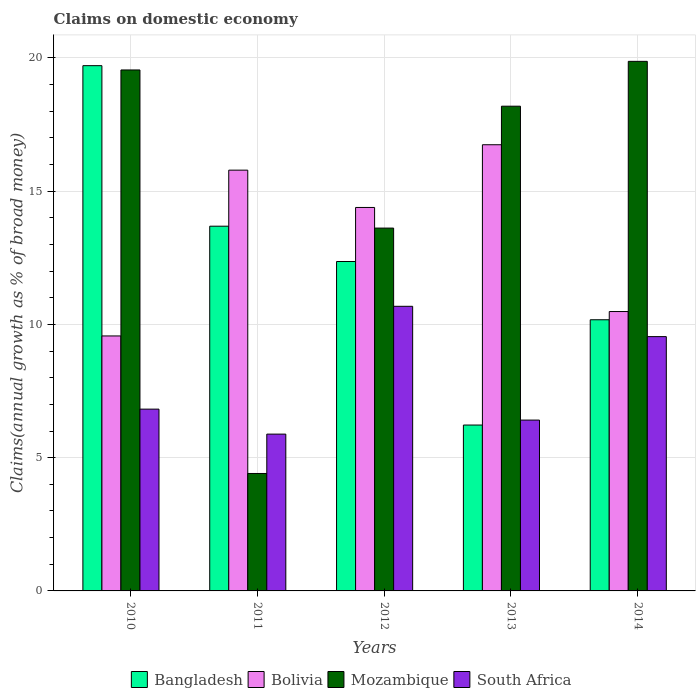How many different coloured bars are there?
Ensure brevity in your answer.  4. How many bars are there on the 5th tick from the left?
Your answer should be very brief. 4. In how many cases, is the number of bars for a given year not equal to the number of legend labels?
Ensure brevity in your answer.  0. What is the percentage of broad money claimed on domestic economy in Bolivia in 2012?
Your answer should be compact. 14.39. Across all years, what is the maximum percentage of broad money claimed on domestic economy in Bangladesh?
Your answer should be very brief. 19.71. Across all years, what is the minimum percentage of broad money claimed on domestic economy in Bolivia?
Offer a terse response. 9.57. In which year was the percentage of broad money claimed on domestic economy in Bangladesh maximum?
Offer a very short reply. 2010. What is the total percentage of broad money claimed on domestic economy in Bangladesh in the graph?
Offer a very short reply. 62.16. What is the difference between the percentage of broad money claimed on domestic economy in Bangladesh in 2013 and that in 2014?
Offer a terse response. -3.95. What is the difference between the percentage of broad money claimed on domestic economy in Bangladesh in 2011 and the percentage of broad money claimed on domestic economy in South Africa in 2012?
Provide a short and direct response. 3.01. What is the average percentage of broad money claimed on domestic economy in Bolivia per year?
Offer a very short reply. 13.39. In the year 2014, what is the difference between the percentage of broad money claimed on domestic economy in Bolivia and percentage of broad money claimed on domestic economy in South Africa?
Give a very brief answer. 0.94. What is the ratio of the percentage of broad money claimed on domestic economy in Bolivia in 2013 to that in 2014?
Give a very brief answer. 1.6. What is the difference between the highest and the second highest percentage of broad money claimed on domestic economy in South Africa?
Ensure brevity in your answer.  1.14. What is the difference between the highest and the lowest percentage of broad money claimed on domestic economy in South Africa?
Offer a very short reply. 4.8. In how many years, is the percentage of broad money claimed on domestic economy in South Africa greater than the average percentage of broad money claimed on domestic economy in South Africa taken over all years?
Your answer should be very brief. 2. Is the sum of the percentage of broad money claimed on domestic economy in South Africa in 2010 and 2012 greater than the maximum percentage of broad money claimed on domestic economy in Mozambique across all years?
Provide a short and direct response. No. Is it the case that in every year, the sum of the percentage of broad money claimed on domestic economy in Mozambique and percentage of broad money claimed on domestic economy in Bolivia is greater than the sum of percentage of broad money claimed on domestic economy in South Africa and percentage of broad money claimed on domestic economy in Bangladesh?
Offer a very short reply. Yes. What does the 4th bar from the right in 2011 represents?
Make the answer very short. Bangladesh. How many years are there in the graph?
Your answer should be very brief. 5. Does the graph contain any zero values?
Your answer should be compact. No. What is the title of the graph?
Your answer should be very brief. Claims on domestic economy. Does "Belize" appear as one of the legend labels in the graph?
Offer a terse response. No. What is the label or title of the Y-axis?
Your response must be concise. Claims(annual growth as % of broad money). What is the Claims(annual growth as % of broad money) of Bangladesh in 2010?
Provide a short and direct response. 19.71. What is the Claims(annual growth as % of broad money) of Bolivia in 2010?
Ensure brevity in your answer.  9.57. What is the Claims(annual growth as % of broad money) in Mozambique in 2010?
Make the answer very short. 19.55. What is the Claims(annual growth as % of broad money) in South Africa in 2010?
Your answer should be compact. 6.82. What is the Claims(annual growth as % of broad money) of Bangladesh in 2011?
Your answer should be compact. 13.69. What is the Claims(annual growth as % of broad money) of Bolivia in 2011?
Your response must be concise. 15.79. What is the Claims(annual growth as % of broad money) in Mozambique in 2011?
Offer a very short reply. 4.41. What is the Claims(annual growth as % of broad money) of South Africa in 2011?
Provide a succinct answer. 5.88. What is the Claims(annual growth as % of broad money) of Bangladesh in 2012?
Ensure brevity in your answer.  12.36. What is the Claims(annual growth as % of broad money) in Bolivia in 2012?
Your response must be concise. 14.39. What is the Claims(annual growth as % of broad money) in Mozambique in 2012?
Give a very brief answer. 13.62. What is the Claims(annual growth as % of broad money) in South Africa in 2012?
Provide a succinct answer. 10.68. What is the Claims(annual growth as % of broad money) of Bangladesh in 2013?
Offer a very short reply. 6.22. What is the Claims(annual growth as % of broad money) in Bolivia in 2013?
Offer a terse response. 16.74. What is the Claims(annual growth as % of broad money) of Mozambique in 2013?
Make the answer very short. 18.19. What is the Claims(annual growth as % of broad money) of South Africa in 2013?
Your response must be concise. 6.41. What is the Claims(annual growth as % of broad money) in Bangladesh in 2014?
Keep it short and to the point. 10.17. What is the Claims(annual growth as % of broad money) in Bolivia in 2014?
Keep it short and to the point. 10.48. What is the Claims(annual growth as % of broad money) of Mozambique in 2014?
Your response must be concise. 19.87. What is the Claims(annual growth as % of broad money) of South Africa in 2014?
Make the answer very short. 9.54. Across all years, what is the maximum Claims(annual growth as % of broad money) of Bangladesh?
Give a very brief answer. 19.71. Across all years, what is the maximum Claims(annual growth as % of broad money) in Bolivia?
Provide a succinct answer. 16.74. Across all years, what is the maximum Claims(annual growth as % of broad money) of Mozambique?
Provide a succinct answer. 19.87. Across all years, what is the maximum Claims(annual growth as % of broad money) of South Africa?
Offer a very short reply. 10.68. Across all years, what is the minimum Claims(annual growth as % of broad money) of Bangladesh?
Make the answer very short. 6.22. Across all years, what is the minimum Claims(annual growth as % of broad money) in Bolivia?
Ensure brevity in your answer.  9.57. Across all years, what is the minimum Claims(annual growth as % of broad money) of Mozambique?
Offer a very short reply. 4.41. Across all years, what is the minimum Claims(annual growth as % of broad money) of South Africa?
Your answer should be very brief. 5.88. What is the total Claims(annual growth as % of broad money) in Bangladesh in the graph?
Offer a very short reply. 62.16. What is the total Claims(annual growth as % of broad money) in Bolivia in the graph?
Your answer should be very brief. 66.97. What is the total Claims(annual growth as % of broad money) in Mozambique in the graph?
Offer a terse response. 75.63. What is the total Claims(annual growth as % of broad money) of South Africa in the graph?
Your answer should be very brief. 39.34. What is the difference between the Claims(annual growth as % of broad money) of Bangladesh in 2010 and that in 2011?
Make the answer very short. 6.02. What is the difference between the Claims(annual growth as % of broad money) of Bolivia in 2010 and that in 2011?
Give a very brief answer. -6.22. What is the difference between the Claims(annual growth as % of broad money) in Mozambique in 2010 and that in 2011?
Provide a succinct answer. 15.14. What is the difference between the Claims(annual growth as % of broad money) of South Africa in 2010 and that in 2011?
Make the answer very short. 0.94. What is the difference between the Claims(annual growth as % of broad money) in Bangladesh in 2010 and that in 2012?
Offer a terse response. 7.35. What is the difference between the Claims(annual growth as % of broad money) in Bolivia in 2010 and that in 2012?
Your answer should be compact. -4.82. What is the difference between the Claims(annual growth as % of broad money) in Mozambique in 2010 and that in 2012?
Give a very brief answer. 5.93. What is the difference between the Claims(annual growth as % of broad money) in South Africa in 2010 and that in 2012?
Provide a succinct answer. -3.86. What is the difference between the Claims(annual growth as % of broad money) of Bangladesh in 2010 and that in 2013?
Ensure brevity in your answer.  13.49. What is the difference between the Claims(annual growth as % of broad money) in Bolivia in 2010 and that in 2013?
Provide a succinct answer. -7.17. What is the difference between the Claims(annual growth as % of broad money) of Mozambique in 2010 and that in 2013?
Give a very brief answer. 1.36. What is the difference between the Claims(annual growth as % of broad money) in South Africa in 2010 and that in 2013?
Your answer should be compact. 0.41. What is the difference between the Claims(annual growth as % of broad money) of Bangladesh in 2010 and that in 2014?
Provide a succinct answer. 9.53. What is the difference between the Claims(annual growth as % of broad money) in Bolivia in 2010 and that in 2014?
Make the answer very short. -0.92. What is the difference between the Claims(annual growth as % of broad money) in Mozambique in 2010 and that in 2014?
Provide a short and direct response. -0.32. What is the difference between the Claims(annual growth as % of broad money) in South Africa in 2010 and that in 2014?
Ensure brevity in your answer.  -2.72. What is the difference between the Claims(annual growth as % of broad money) in Bangladesh in 2011 and that in 2012?
Provide a succinct answer. 1.32. What is the difference between the Claims(annual growth as % of broad money) of Bolivia in 2011 and that in 2012?
Offer a very short reply. 1.4. What is the difference between the Claims(annual growth as % of broad money) in Mozambique in 2011 and that in 2012?
Offer a terse response. -9.21. What is the difference between the Claims(annual growth as % of broad money) in South Africa in 2011 and that in 2012?
Offer a terse response. -4.8. What is the difference between the Claims(annual growth as % of broad money) in Bangladesh in 2011 and that in 2013?
Keep it short and to the point. 7.46. What is the difference between the Claims(annual growth as % of broad money) of Bolivia in 2011 and that in 2013?
Your answer should be very brief. -0.95. What is the difference between the Claims(annual growth as % of broad money) of Mozambique in 2011 and that in 2013?
Give a very brief answer. -13.78. What is the difference between the Claims(annual growth as % of broad money) in South Africa in 2011 and that in 2013?
Ensure brevity in your answer.  -0.53. What is the difference between the Claims(annual growth as % of broad money) of Bangladesh in 2011 and that in 2014?
Your response must be concise. 3.51. What is the difference between the Claims(annual growth as % of broad money) of Bolivia in 2011 and that in 2014?
Ensure brevity in your answer.  5.31. What is the difference between the Claims(annual growth as % of broad money) of Mozambique in 2011 and that in 2014?
Your answer should be compact. -15.46. What is the difference between the Claims(annual growth as % of broad money) in South Africa in 2011 and that in 2014?
Ensure brevity in your answer.  -3.66. What is the difference between the Claims(annual growth as % of broad money) of Bangladesh in 2012 and that in 2013?
Provide a succinct answer. 6.14. What is the difference between the Claims(annual growth as % of broad money) of Bolivia in 2012 and that in 2013?
Give a very brief answer. -2.35. What is the difference between the Claims(annual growth as % of broad money) of Mozambique in 2012 and that in 2013?
Keep it short and to the point. -4.57. What is the difference between the Claims(annual growth as % of broad money) in South Africa in 2012 and that in 2013?
Provide a short and direct response. 4.27. What is the difference between the Claims(annual growth as % of broad money) in Bangladesh in 2012 and that in 2014?
Your answer should be very brief. 2.19. What is the difference between the Claims(annual growth as % of broad money) in Bolivia in 2012 and that in 2014?
Make the answer very short. 3.91. What is the difference between the Claims(annual growth as % of broad money) in Mozambique in 2012 and that in 2014?
Offer a terse response. -6.26. What is the difference between the Claims(annual growth as % of broad money) in South Africa in 2012 and that in 2014?
Provide a short and direct response. 1.14. What is the difference between the Claims(annual growth as % of broad money) of Bangladesh in 2013 and that in 2014?
Offer a very short reply. -3.95. What is the difference between the Claims(annual growth as % of broad money) in Bolivia in 2013 and that in 2014?
Give a very brief answer. 6.26. What is the difference between the Claims(annual growth as % of broad money) of Mozambique in 2013 and that in 2014?
Provide a short and direct response. -1.68. What is the difference between the Claims(annual growth as % of broad money) in South Africa in 2013 and that in 2014?
Your response must be concise. -3.13. What is the difference between the Claims(annual growth as % of broad money) of Bangladesh in 2010 and the Claims(annual growth as % of broad money) of Bolivia in 2011?
Make the answer very short. 3.92. What is the difference between the Claims(annual growth as % of broad money) in Bangladesh in 2010 and the Claims(annual growth as % of broad money) in Mozambique in 2011?
Ensure brevity in your answer.  15.3. What is the difference between the Claims(annual growth as % of broad money) in Bangladesh in 2010 and the Claims(annual growth as % of broad money) in South Africa in 2011?
Make the answer very short. 13.83. What is the difference between the Claims(annual growth as % of broad money) of Bolivia in 2010 and the Claims(annual growth as % of broad money) of Mozambique in 2011?
Offer a very short reply. 5.16. What is the difference between the Claims(annual growth as % of broad money) in Bolivia in 2010 and the Claims(annual growth as % of broad money) in South Africa in 2011?
Your answer should be very brief. 3.68. What is the difference between the Claims(annual growth as % of broad money) in Mozambique in 2010 and the Claims(annual growth as % of broad money) in South Africa in 2011?
Make the answer very short. 13.66. What is the difference between the Claims(annual growth as % of broad money) in Bangladesh in 2010 and the Claims(annual growth as % of broad money) in Bolivia in 2012?
Give a very brief answer. 5.32. What is the difference between the Claims(annual growth as % of broad money) in Bangladesh in 2010 and the Claims(annual growth as % of broad money) in Mozambique in 2012?
Your response must be concise. 6.09. What is the difference between the Claims(annual growth as % of broad money) in Bangladesh in 2010 and the Claims(annual growth as % of broad money) in South Africa in 2012?
Ensure brevity in your answer.  9.03. What is the difference between the Claims(annual growth as % of broad money) in Bolivia in 2010 and the Claims(annual growth as % of broad money) in Mozambique in 2012?
Make the answer very short. -4.05. What is the difference between the Claims(annual growth as % of broad money) in Bolivia in 2010 and the Claims(annual growth as % of broad money) in South Africa in 2012?
Provide a succinct answer. -1.11. What is the difference between the Claims(annual growth as % of broad money) in Mozambique in 2010 and the Claims(annual growth as % of broad money) in South Africa in 2012?
Provide a short and direct response. 8.87. What is the difference between the Claims(annual growth as % of broad money) in Bangladesh in 2010 and the Claims(annual growth as % of broad money) in Bolivia in 2013?
Provide a short and direct response. 2.97. What is the difference between the Claims(annual growth as % of broad money) in Bangladesh in 2010 and the Claims(annual growth as % of broad money) in Mozambique in 2013?
Provide a succinct answer. 1.52. What is the difference between the Claims(annual growth as % of broad money) of Bangladesh in 2010 and the Claims(annual growth as % of broad money) of South Africa in 2013?
Offer a very short reply. 13.3. What is the difference between the Claims(annual growth as % of broad money) in Bolivia in 2010 and the Claims(annual growth as % of broad money) in Mozambique in 2013?
Provide a succinct answer. -8.62. What is the difference between the Claims(annual growth as % of broad money) of Bolivia in 2010 and the Claims(annual growth as % of broad money) of South Africa in 2013?
Offer a very short reply. 3.16. What is the difference between the Claims(annual growth as % of broad money) of Mozambique in 2010 and the Claims(annual growth as % of broad money) of South Africa in 2013?
Offer a terse response. 13.14. What is the difference between the Claims(annual growth as % of broad money) in Bangladesh in 2010 and the Claims(annual growth as % of broad money) in Bolivia in 2014?
Give a very brief answer. 9.23. What is the difference between the Claims(annual growth as % of broad money) in Bangladesh in 2010 and the Claims(annual growth as % of broad money) in Mozambique in 2014?
Your answer should be compact. -0.16. What is the difference between the Claims(annual growth as % of broad money) in Bangladesh in 2010 and the Claims(annual growth as % of broad money) in South Africa in 2014?
Keep it short and to the point. 10.17. What is the difference between the Claims(annual growth as % of broad money) in Bolivia in 2010 and the Claims(annual growth as % of broad money) in Mozambique in 2014?
Your answer should be compact. -10.3. What is the difference between the Claims(annual growth as % of broad money) of Bolivia in 2010 and the Claims(annual growth as % of broad money) of South Africa in 2014?
Ensure brevity in your answer.  0.03. What is the difference between the Claims(annual growth as % of broad money) in Mozambique in 2010 and the Claims(annual growth as % of broad money) in South Africa in 2014?
Your answer should be very brief. 10.01. What is the difference between the Claims(annual growth as % of broad money) in Bangladesh in 2011 and the Claims(annual growth as % of broad money) in Bolivia in 2012?
Ensure brevity in your answer.  -0.7. What is the difference between the Claims(annual growth as % of broad money) in Bangladesh in 2011 and the Claims(annual growth as % of broad money) in Mozambique in 2012?
Give a very brief answer. 0.07. What is the difference between the Claims(annual growth as % of broad money) of Bangladesh in 2011 and the Claims(annual growth as % of broad money) of South Africa in 2012?
Offer a terse response. 3.01. What is the difference between the Claims(annual growth as % of broad money) of Bolivia in 2011 and the Claims(annual growth as % of broad money) of Mozambique in 2012?
Provide a succinct answer. 2.17. What is the difference between the Claims(annual growth as % of broad money) of Bolivia in 2011 and the Claims(annual growth as % of broad money) of South Africa in 2012?
Your response must be concise. 5.11. What is the difference between the Claims(annual growth as % of broad money) of Mozambique in 2011 and the Claims(annual growth as % of broad money) of South Africa in 2012?
Keep it short and to the point. -6.27. What is the difference between the Claims(annual growth as % of broad money) in Bangladesh in 2011 and the Claims(annual growth as % of broad money) in Bolivia in 2013?
Offer a very short reply. -3.06. What is the difference between the Claims(annual growth as % of broad money) of Bangladesh in 2011 and the Claims(annual growth as % of broad money) of Mozambique in 2013?
Provide a succinct answer. -4.5. What is the difference between the Claims(annual growth as % of broad money) in Bangladesh in 2011 and the Claims(annual growth as % of broad money) in South Africa in 2013?
Provide a succinct answer. 7.28. What is the difference between the Claims(annual growth as % of broad money) of Bolivia in 2011 and the Claims(annual growth as % of broad money) of Mozambique in 2013?
Your response must be concise. -2.4. What is the difference between the Claims(annual growth as % of broad money) in Bolivia in 2011 and the Claims(annual growth as % of broad money) in South Africa in 2013?
Ensure brevity in your answer.  9.38. What is the difference between the Claims(annual growth as % of broad money) of Mozambique in 2011 and the Claims(annual growth as % of broad money) of South Africa in 2013?
Make the answer very short. -2. What is the difference between the Claims(annual growth as % of broad money) of Bangladesh in 2011 and the Claims(annual growth as % of broad money) of Bolivia in 2014?
Provide a short and direct response. 3.2. What is the difference between the Claims(annual growth as % of broad money) of Bangladesh in 2011 and the Claims(annual growth as % of broad money) of Mozambique in 2014?
Your response must be concise. -6.19. What is the difference between the Claims(annual growth as % of broad money) of Bangladesh in 2011 and the Claims(annual growth as % of broad money) of South Africa in 2014?
Offer a very short reply. 4.14. What is the difference between the Claims(annual growth as % of broad money) in Bolivia in 2011 and the Claims(annual growth as % of broad money) in Mozambique in 2014?
Ensure brevity in your answer.  -4.08. What is the difference between the Claims(annual growth as % of broad money) in Bolivia in 2011 and the Claims(annual growth as % of broad money) in South Africa in 2014?
Keep it short and to the point. 6.25. What is the difference between the Claims(annual growth as % of broad money) in Mozambique in 2011 and the Claims(annual growth as % of broad money) in South Africa in 2014?
Keep it short and to the point. -5.14. What is the difference between the Claims(annual growth as % of broad money) in Bangladesh in 2012 and the Claims(annual growth as % of broad money) in Bolivia in 2013?
Provide a short and direct response. -4.38. What is the difference between the Claims(annual growth as % of broad money) in Bangladesh in 2012 and the Claims(annual growth as % of broad money) in Mozambique in 2013?
Your response must be concise. -5.83. What is the difference between the Claims(annual growth as % of broad money) in Bangladesh in 2012 and the Claims(annual growth as % of broad money) in South Africa in 2013?
Offer a very short reply. 5.95. What is the difference between the Claims(annual growth as % of broad money) of Bolivia in 2012 and the Claims(annual growth as % of broad money) of Mozambique in 2013?
Offer a terse response. -3.8. What is the difference between the Claims(annual growth as % of broad money) in Bolivia in 2012 and the Claims(annual growth as % of broad money) in South Africa in 2013?
Offer a terse response. 7.98. What is the difference between the Claims(annual growth as % of broad money) in Mozambique in 2012 and the Claims(annual growth as % of broad money) in South Africa in 2013?
Your answer should be compact. 7.2. What is the difference between the Claims(annual growth as % of broad money) of Bangladesh in 2012 and the Claims(annual growth as % of broad money) of Bolivia in 2014?
Your answer should be compact. 1.88. What is the difference between the Claims(annual growth as % of broad money) of Bangladesh in 2012 and the Claims(annual growth as % of broad money) of Mozambique in 2014?
Offer a terse response. -7.51. What is the difference between the Claims(annual growth as % of broad money) of Bangladesh in 2012 and the Claims(annual growth as % of broad money) of South Africa in 2014?
Ensure brevity in your answer.  2.82. What is the difference between the Claims(annual growth as % of broad money) of Bolivia in 2012 and the Claims(annual growth as % of broad money) of Mozambique in 2014?
Give a very brief answer. -5.48. What is the difference between the Claims(annual growth as % of broad money) in Bolivia in 2012 and the Claims(annual growth as % of broad money) in South Africa in 2014?
Your answer should be compact. 4.85. What is the difference between the Claims(annual growth as % of broad money) in Mozambique in 2012 and the Claims(annual growth as % of broad money) in South Africa in 2014?
Offer a terse response. 4.07. What is the difference between the Claims(annual growth as % of broad money) in Bangladesh in 2013 and the Claims(annual growth as % of broad money) in Bolivia in 2014?
Your response must be concise. -4.26. What is the difference between the Claims(annual growth as % of broad money) of Bangladesh in 2013 and the Claims(annual growth as % of broad money) of Mozambique in 2014?
Ensure brevity in your answer.  -13.65. What is the difference between the Claims(annual growth as % of broad money) in Bangladesh in 2013 and the Claims(annual growth as % of broad money) in South Africa in 2014?
Keep it short and to the point. -3.32. What is the difference between the Claims(annual growth as % of broad money) of Bolivia in 2013 and the Claims(annual growth as % of broad money) of Mozambique in 2014?
Provide a succinct answer. -3.13. What is the difference between the Claims(annual growth as % of broad money) in Bolivia in 2013 and the Claims(annual growth as % of broad money) in South Africa in 2014?
Provide a short and direct response. 7.2. What is the difference between the Claims(annual growth as % of broad money) of Mozambique in 2013 and the Claims(annual growth as % of broad money) of South Africa in 2014?
Give a very brief answer. 8.65. What is the average Claims(annual growth as % of broad money) in Bangladesh per year?
Your response must be concise. 12.43. What is the average Claims(annual growth as % of broad money) in Bolivia per year?
Your answer should be compact. 13.39. What is the average Claims(annual growth as % of broad money) in Mozambique per year?
Give a very brief answer. 15.13. What is the average Claims(annual growth as % of broad money) in South Africa per year?
Your answer should be very brief. 7.87. In the year 2010, what is the difference between the Claims(annual growth as % of broad money) in Bangladesh and Claims(annual growth as % of broad money) in Bolivia?
Offer a terse response. 10.14. In the year 2010, what is the difference between the Claims(annual growth as % of broad money) in Bangladesh and Claims(annual growth as % of broad money) in Mozambique?
Give a very brief answer. 0.16. In the year 2010, what is the difference between the Claims(annual growth as % of broad money) in Bangladesh and Claims(annual growth as % of broad money) in South Africa?
Keep it short and to the point. 12.89. In the year 2010, what is the difference between the Claims(annual growth as % of broad money) in Bolivia and Claims(annual growth as % of broad money) in Mozambique?
Provide a short and direct response. -9.98. In the year 2010, what is the difference between the Claims(annual growth as % of broad money) of Bolivia and Claims(annual growth as % of broad money) of South Africa?
Give a very brief answer. 2.75. In the year 2010, what is the difference between the Claims(annual growth as % of broad money) of Mozambique and Claims(annual growth as % of broad money) of South Africa?
Your answer should be very brief. 12.73. In the year 2011, what is the difference between the Claims(annual growth as % of broad money) of Bangladesh and Claims(annual growth as % of broad money) of Bolivia?
Give a very brief answer. -2.1. In the year 2011, what is the difference between the Claims(annual growth as % of broad money) in Bangladesh and Claims(annual growth as % of broad money) in Mozambique?
Your response must be concise. 9.28. In the year 2011, what is the difference between the Claims(annual growth as % of broad money) of Bangladesh and Claims(annual growth as % of broad money) of South Africa?
Keep it short and to the point. 7.8. In the year 2011, what is the difference between the Claims(annual growth as % of broad money) of Bolivia and Claims(annual growth as % of broad money) of Mozambique?
Your response must be concise. 11.38. In the year 2011, what is the difference between the Claims(annual growth as % of broad money) of Bolivia and Claims(annual growth as % of broad money) of South Africa?
Keep it short and to the point. 9.91. In the year 2011, what is the difference between the Claims(annual growth as % of broad money) of Mozambique and Claims(annual growth as % of broad money) of South Africa?
Give a very brief answer. -1.48. In the year 2012, what is the difference between the Claims(annual growth as % of broad money) in Bangladesh and Claims(annual growth as % of broad money) in Bolivia?
Keep it short and to the point. -2.03. In the year 2012, what is the difference between the Claims(annual growth as % of broad money) of Bangladesh and Claims(annual growth as % of broad money) of Mozambique?
Keep it short and to the point. -1.25. In the year 2012, what is the difference between the Claims(annual growth as % of broad money) of Bangladesh and Claims(annual growth as % of broad money) of South Africa?
Make the answer very short. 1.68. In the year 2012, what is the difference between the Claims(annual growth as % of broad money) in Bolivia and Claims(annual growth as % of broad money) in Mozambique?
Offer a terse response. 0.77. In the year 2012, what is the difference between the Claims(annual growth as % of broad money) of Bolivia and Claims(annual growth as % of broad money) of South Africa?
Your answer should be compact. 3.71. In the year 2012, what is the difference between the Claims(annual growth as % of broad money) of Mozambique and Claims(annual growth as % of broad money) of South Africa?
Give a very brief answer. 2.94. In the year 2013, what is the difference between the Claims(annual growth as % of broad money) of Bangladesh and Claims(annual growth as % of broad money) of Bolivia?
Give a very brief answer. -10.52. In the year 2013, what is the difference between the Claims(annual growth as % of broad money) of Bangladesh and Claims(annual growth as % of broad money) of Mozambique?
Give a very brief answer. -11.96. In the year 2013, what is the difference between the Claims(annual growth as % of broad money) of Bangladesh and Claims(annual growth as % of broad money) of South Africa?
Your answer should be very brief. -0.19. In the year 2013, what is the difference between the Claims(annual growth as % of broad money) in Bolivia and Claims(annual growth as % of broad money) in Mozambique?
Your answer should be compact. -1.45. In the year 2013, what is the difference between the Claims(annual growth as % of broad money) of Bolivia and Claims(annual growth as % of broad money) of South Africa?
Keep it short and to the point. 10.33. In the year 2013, what is the difference between the Claims(annual growth as % of broad money) in Mozambique and Claims(annual growth as % of broad money) in South Africa?
Offer a very short reply. 11.78. In the year 2014, what is the difference between the Claims(annual growth as % of broad money) of Bangladesh and Claims(annual growth as % of broad money) of Bolivia?
Provide a short and direct response. -0.31. In the year 2014, what is the difference between the Claims(annual growth as % of broad money) of Bangladesh and Claims(annual growth as % of broad money) of Mozambique?
Provide a succinct answer. -9.7. In the year 2014, what is the difference between the Claims(annual growth as % of broad money) in Bangladesh and Claims(annual growth as % of broad money) in South Africa?
Your response must be concise. 0.63. In the year 2014, what is the difference between the Claims(annual growth as % of broad money) in Bolivia and Claims(annual growth as % of broad money) in Mozambique?
Make the answer very short. -9.39. In the year 2014, what is the difference between the Claims(annual growth as % of broad money) of Bolivia and Claims(annual growth as % of broad money) of South Africa?
Make the answer very short. 0.94. In the year 2014, what is the difference between the Claims(annual growth as % of broad money) in Mozambique and Claims(annual growth as % of broad money) in South Africa?
Provide a succinct answer. 10.33. What is the ratio of the Claims(annual growth as % of broad money) of Bangladesh in 2010 to that in 2011?
Offer a very short reply. 1.44. What is the ratio of the Claims(annual growth as % of broad money) of Bolivia in 2010 to that in 2011?
Provide a succinct answer. 0.61. What is the ratio of the Claims(annual growth as % of broad money) of Mozambique in 2010 to that in 2011?
Provide a succinct answer. 4.44. What is the ratio of the Claims(annual growth as % of broad money) of South Africa in 2010 to that in 2011?
Your answer should be compact. 1.16. What is the ratio of the Claims(annual growth as % of broad money) in Bangladesh in 2010 to that in 2012?
Ensure brevity in your answer.  1.59. What is the ratio of the Claims(annual growth as % of broad money) in Bolivia in 2010 to that in 2012?
Your answer should be compact. 0.66. What is the ratio of the Claims(annual growth as % of broad money) of Mozambique in 2010 to that in 2012?
Your response must be concise. 1.44. What is the ratio of the Claims(annual growth as % of broad money) of South Africa in 2010 to that in 2012?
Provide a succinct answer. 0.64. What is the ratio of the Claims(annual growth as % of broad money) of Bangladesh in 2010 to that in 2013?
Provide a succinct answer. 3.17. What is the ratio of the Claims(annual growth as % of broad money) in Bolivia in 2010 to that in 2013?
Offer a terse response. 0.57. What is the ratio of the Claims(annual growth as % of broad money) in Mozambique in 2010 to that in 2013?
Keep it short and to the point. 1.07. What is the ratio of the Claims(annual growth as % of broad money) in South Africa in 2010 to that in 2013?
Keep it short and to the point. 1.06. What is the ratio of the Claims(annual growth as % of broad money) of Bangladesh in 2010 to that in 2014?
Your answer should be compact. 1.94. What is the ratio of the Claims(annual growth as % of broad money) of Bolivia in 2010 to that in 2014?
Offer a terse response. 0.91. What is the ratio of the Claims(annual growth as % of broad money) in Mozambique in 2010 to that in 2014?
Make the answer very short. 0.98. What is the ratio of the Claims(annual growth as % of broad money) of South Africa in 2010 to that in 2014?
Your answer should be compact. 0.71. What is the ratio of the Claims(annual growth as % of broad money) of Bangladesh in 2011 to that in 2012?
Your answer should be compact. 1.11. What is the ratio of the Claims(annual growth as % of broad money) of Bolivia in 2011 to that in 2012?
Offer a very short reply. 1.1. What is the ratio of the Claims(annual growth as % of broad money) of Mozambique in 2011 to that in 2012?
Provide a short and direct response. 0.32. What is the ratio of the Claims(annual growth as % of broad money) of South Africa in 2011 to that in 2012?
Ensure brevity in your answer.  0.55. What is the ratio of the Claims(annual growth as % of broad money) of Bangladesh in 2011 to that in 2013?
Your answer should be very brief. 2.2. What is the ratio of the Claims(annual growth as % of broad money) of Bolivia in 2011 to that in 2013?
Ensure brevity in your answer.  0.94. What is the ratio of the Claims(annual growth as % of broad money) in Mozambique in 2011 to that in 2013?
Your answer should be very brief. 0.24. What is the ratio of the Claims(annual growth as % of broad money) of South Africa in 2011 to that in 2013?
Offer a very short reply. 0.92. What is the ratio of the Claims(annual growth as % of broad money) in Bangladesh in 2011 to that in 2014?
Your answer should be compact. 1.35. What is the ratio of the Claims(annual growth as % of broad money) of Bolivia in 2011 to that in 2014?
Provide a short and direct response. 1.51. What is the ratio of the Claims(annual growth as % of broad money) in Mozambique in 2011 to that in 2014?
Offer a very short reply. 0.22. What is the ratio of the Claims(annual growth as % of broad money) of South Africa in 2011 to that in 2014?
Offer a very short reply. 0.62. What is the ratio of the Claims(annual growth as % of broad money) of Bangladesh in 2012 to that in 2013?
Give a very brief answer. 1.99. What is the ratio of the Claims(annual growth as % of broad money) in Bolivia in 2012 to that in 2013?
Your response must be concise. 0.86. What is the ratio of the Claims(annual growth as % of broad money) in Mozambique in 2012 to that in 2013?
Give a very brief answer. 0.75. What is the ratio of the Claims(annual growth as % of broad money) of South Africa in 2012 to that in 2013?
Ensure brevity in your answer.  1.67. What is the ratio of the Claims(annual growth as % of broad money) of Bangladesh in 2012 to that in 2014?
Provide a short and direct response. 1.21. What is the ratio of the Claims(annual growth as % of broad money) of Bolivia in 2012 to that in 2014?
Provide a succinct answer. 1.37. What is the ratio of the Claims(annual growth as % of broad money) in Mozambique in 2012 to that in 2014?
Your answer should be very brief. 0.69. What is the ratio of the Claims(annual growth as % of broad money) of South Africa in 2012 to that in 2014?
Your answer should be compact. 1.12. What is the ratio of the Claims(annual growth as % of broad money) in Bangladesh in 2013 to that in 2014?
Your response must be concise. 0.61. What is the ratio of the Claims(annual growth as % of broad money) of Bolivia in 2013 to that in 2014?
Keep it short and to the point. 1.6. What is the ratio of the Claims(annual growth as % of broad money) of Mozambique in 2013 to that in 2014?
Give a very brief answer. 0.92. What is the ratio of the Claims(annual growth as % of broad money) of South Africa in 2013 to that in 2014?
Offer a terse response. 0.67. What is the difference between the highest and the second highest Claims(annual growth as % of broad money) of Bangladesh?
Provide a short and direct response. 6.02. What is the difference between the highest and the second highest Claims(annual growth as % of broad money) in Bolivia?
Make the answer very short. 0.95. What is the difference between the highest and the second highest Claims(annual growth as % of broad money) of Mozambique?
Offer a terse response. 0.32. What is the difference between the highest and the second highest Claims(annual growth as % of broad money) of South Africa?
Offer a terse response. 1.14. What is the difference between the highest and the lowest Claims(annual growth as % of broad money) in Bangladesh?
Offer a terse response. 13.49. What is the difference between the highest and the lowest Claims(annual growth as % of broad money) of Bolivia?
Provide a short and direct response. 7.17. What is the difference between the highest and the lowest Claims(annual growth as % of broad money) of Mozambique?
Your answer should be very brief. 15.46. What is the difference between the highest and the lowest Claims(annual growth as % of broad money) of South Africa?
Ensure brevity in your answer.  4.8. 